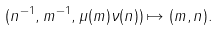<formula> <loc_0><loc_0><loc_500><loc_500>( n ^ { - 1 } , m ^ { - 1 } , \mu ( m ) \nu ( n ) ) \mapsto ( m , n ) .</formula> 